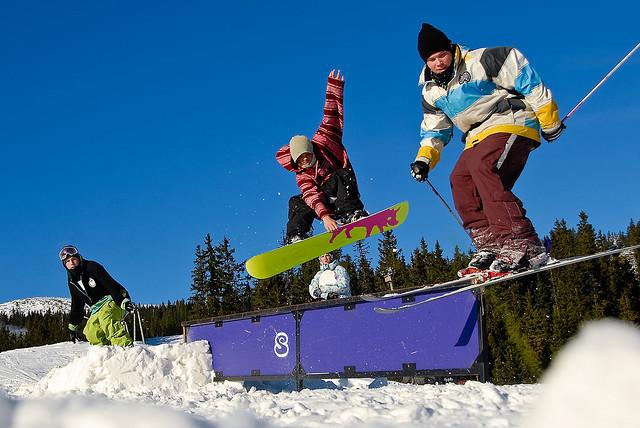Could they be skiing together?
Quick response, please. Yes. What color is the snowboard?
Answer briefly. Yellow. What color are the front persons pants?
Give a very brief answer. Brown. 